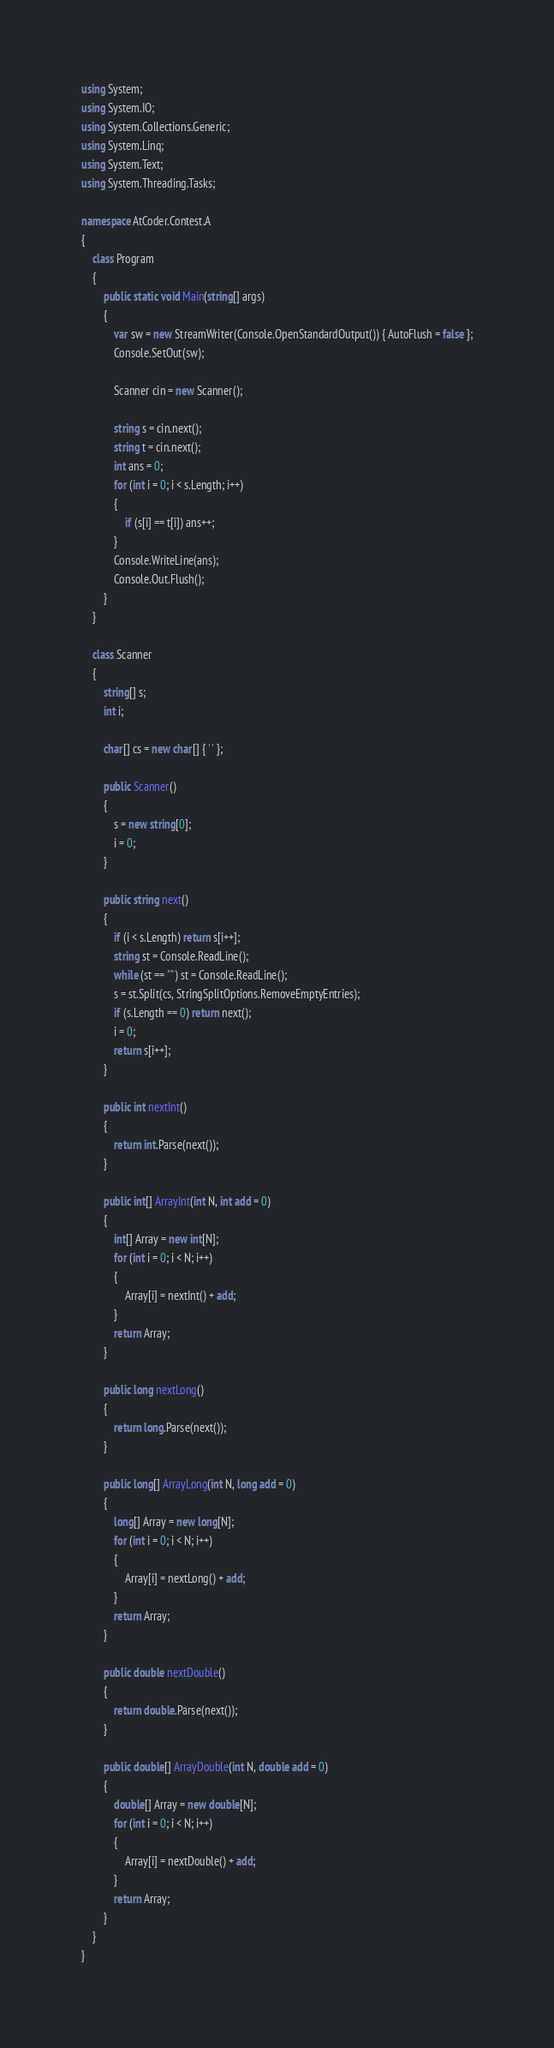<code> <loc_0><loc_0><loc_500><loc_500><_C#_>using System;
using System.IO;
using System.Collections.Generic;
using System.Linq;
using System.Text;
using System.Threading.Tasks;

namespace AtCoder.Contest.A
{
	class Program
	{
		public static void Main(string[] args)
		{
			var sw = new StreamWriter(Console.OpenStandardOutput()) { AutoFlush = false };
			Console.SetOut(sw);

			Scanner cin = new Scanner();

			string s = cin.next();
			string t = cin.next();
			int ans = 0;
			for (int i = 0; i < s.Length; i++)
			{
				if (s[i] == t[i]) ans++;
			}
			Console.WriteLine(ans);
			Console.Out.Flush();
		}
	}

	class Scanner
	{
		string[] s;
		int i;

		char[] cs = new char[] { ' ' };

		public Scanner()
		{
			s = new string[0];
			i = 0;
		}

		public string next()
		{
			if (i < s.Length) return s[i++];
			string st = Console.ReadLine();
			while (st == "") st = Console.ReadLine();
			s = st.Split(cs, StringSplitOptions.RemoveEmptyEntries);
			if (s.Length == 0) return next();
			i = 0;
			return s[i++];
		}

		public int nextInt()
		{
			return int.Parse(next());
		}

		public int[] ArrayInt(int N, int add = 0)
		{
			int[] Array = new int[N];
			for (int i = 0; i < N; i++)
			{
				Array[i] = nextInt() + add;
			}
			return Array;
		}

		public long nextLong()
		{
			return long.Parse(next());
		}

		public long[] ArrayLong(int N, long add = 0)
		{
			long[] Array = new long[N];
			for (int i = 0; i < N; i++)
			{
				Array[i] = nextLong() + add;
			}
			return Array;
		}

		public double nextDouble()
		{
			return double.Parse(next());
		}

		public double[] ArrayDouble(int N, double add = 0)
		{
			double[] Array = new double[N];
			for (int i = 0; i < N; i++)
			{
				Array[i] = nextDouble() + add;
			}
			return Array;
		}
	}
}</code> 